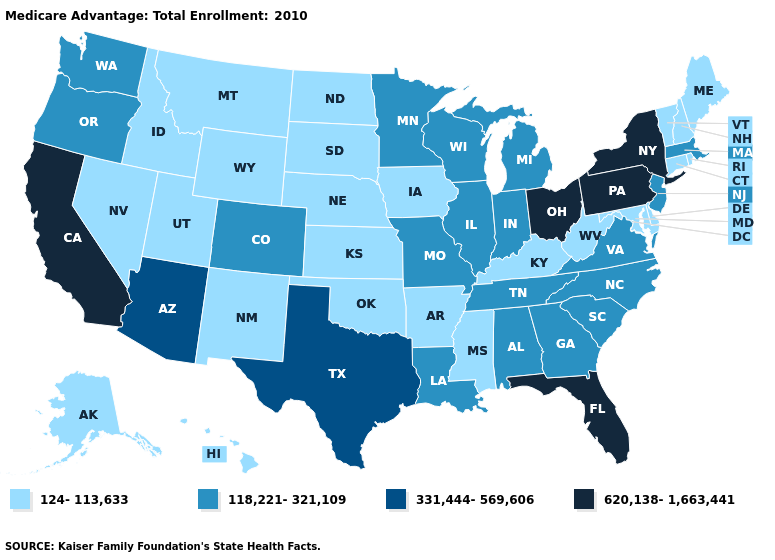What is the value of Connecticut?
Answer briefly. 124-113,633. What is the value of Tennessee?
Answer briefly. 118,221-321,109. Does Arkansas have the lowest value in the USA?
Write a very short answer. Yes. Does South Carolina have a higher value than Wisconsin?
Be succinct. No. What is the value of Oklahoma?
Short answer required. 124-113,633. Does Maryland have a lower value than Alaska?
Answer briefly. No. Does California have the highest value in the USA?
Be succinct. Yes. Which states have the lowest value in the USA?
Keep it brief. Alaska, Arkansas, Connecticut, Delaware, Hawaii, Iowa, Idaho, Kansas, Kentucky, Maryland, Maine, Mississippi, Montana, North Dakota, Nebraska, New Hampshire, New Mexico, Nevada, Oklahoma, Rhode Island, South Dakota, Utah, Vermont, West Virginia, Wyoming. What is the highest value in the MidWest ?
Keep it brief. 620,138-1,663,441. Name the states that have a value in the range 118,221-321,109?
Answer briefly. Alabama, Colorado, Georgia, Illinois, Indiana, Louisiana, Massachusetts, Michigan, Minnesota, Missouri, North Carolina, New Jersey, Oregon, South Carolina, Tennessee, Virginia, Washington, Wisconsin. Does the map have missing data?
Quick response, please. No. Name the states that have a value in the range 118,221-321,109?
Short answer required. Alabama, Colorado, Georgia, Illinois, Indiana, Louisiana, Massachusetts, Michigan, Minnesota, Missouri, North Carolina, New Jersey, Oregon, South Carolina, Tennessee, Virginia, Washington, Wisconsin. What is the value of New Jersey?
Give a very brief answer. 118,221-321,109. Among the states that border Nevada , which have the lowest value?
Give a very brief answer. Idaho, Utah. Among the states that border Kansas , which have the lowest value?
Answer briefly. Nebraska, Oklahoma. 